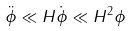Convert formula to latex. <formula><loc_0><loc_0><loc_500><loc_500>\ddot { \phi } \ll H \dot { \phi } \ll H ^ { 2 } \phi</formula> 